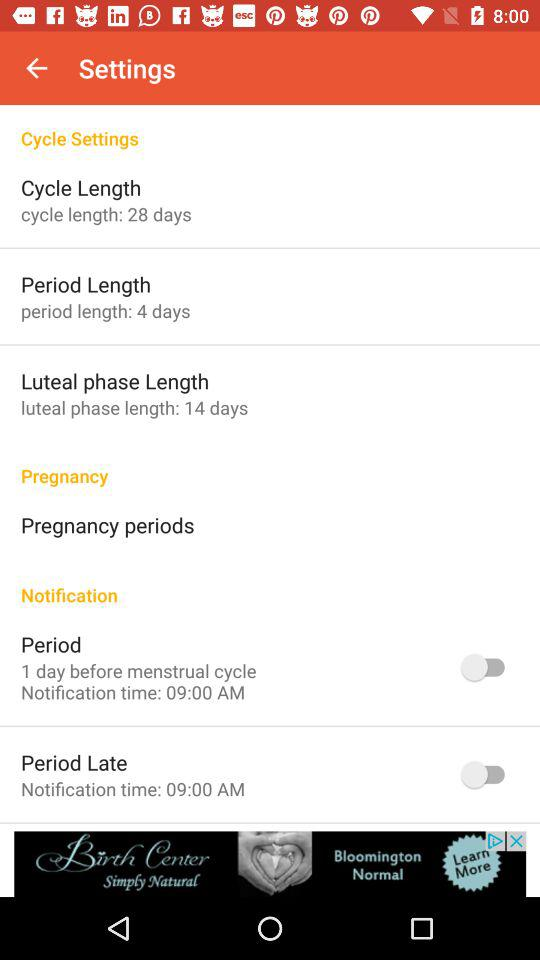What is the cycle length in the settings? The cycle length in the settings is 28 days. 